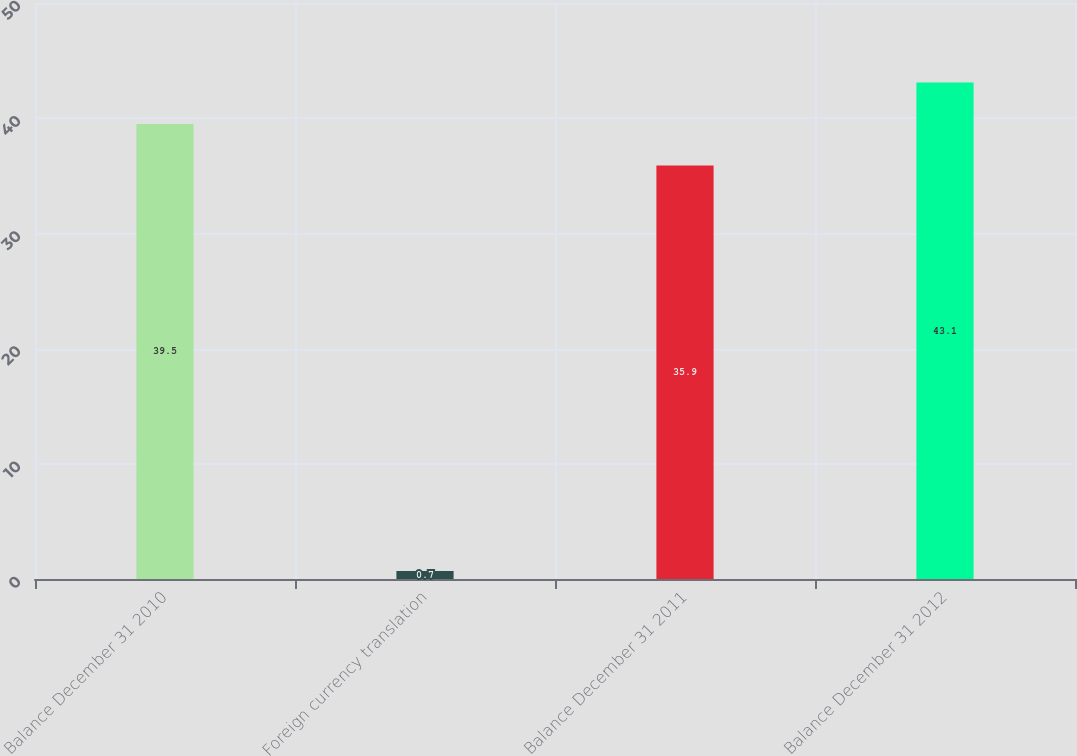<chart> <loc_0><loc_0><loc_500><loc_500><bar_chart><fcel>Balance December 31 2010<fcel>Foreign currency translation<fcel>Balance December 31 2011<fcel>Balance December 31 2012<nl><fcel>39.5<fcel>0.7<fcel>35.9<fcel>43.1<nl></chart> 